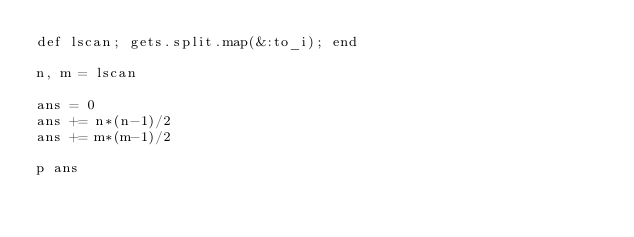Convert code to text. <code><loc_0><loc_0><loc_500><loc_500><_Ruby_>def lscan; gets.split.map(&:to_i); end

n, m = lscan

ans = 0
ans += n*(n-1)/2
ans += m*(m-1)/2

p ans</code> 